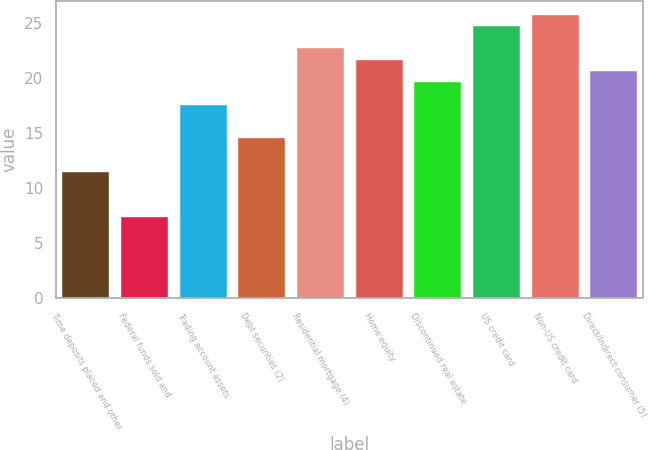<chart> <loc_0><loc_0><loc_500><loc_500><bar_chart><fcel>Time deposits placed and other<fcel>Federal funds sold and<fcel>Trading account assets<fcel>Debt securities (2)<fcel>Residential mortgage (4)<fcel>Home equity<fcel>Discontinued real estate<fcel>US credit card<fcel>Non-US credit card<fcel>Direct/Indirect consumer (5)<nl><fcel>11.46<fcel>7.35<fcel>17.61<fcel>14.54<fcel>22.72<fcel>21.7<fcel>19.65<fcel>24.76<fcel>25.79<fcel>20.67<nl></chart> 